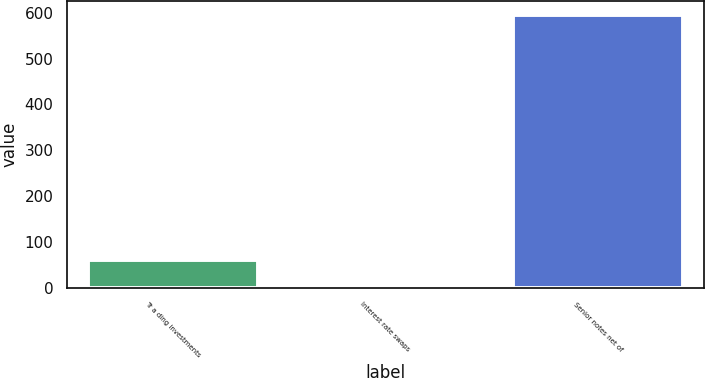Convert chart. <chart><loc_0><loc_0><loc_500><loc_500><bar_chart><fcel>Tr a ding investments<fcel>Interest rate swaps<fcel>Senior notes net of<nl><fcel>60.82<fcel>1.4<fcel>595.6<nl></chart> 